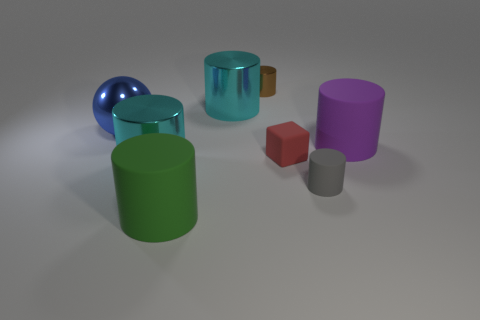Subtract 1 cylinders. How many cylinders are left? 5 Subtract all tiny gray rubber cylinders. How many cylinders are left? 5 Subtract all green cylinders. How many cylinders are left? 5 Subtract all brown cylinders. Subtract all gray blocks. How many cylinders are left? 5 Add 1 green matte objects. How many objects exist? 9 Subtract all balls. How many objects are left? 7 Subtract all red rubber things. Subtract all red rubber objects. How many objects are left? 6 Add 6 large matte cylinders. How many large matte cylinders are left? 8 Add 1 large red things. How many large red things exist? 1 Subtract 0 brown cubes. How many objects are left? 8 